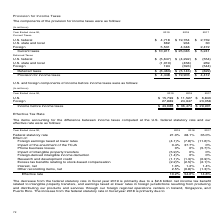According to Microsoft Corporation's financial document, Why did effective tax rate in fiscal 2019 decrease from 2018? Based on the financial document, the answer is The decrease in our effective tax rate for fiscal year 2019 compared to fiscal year 2018 was primarily due to the net charge related to the enactment of the TCJA in the second quarter of fiscal year 2018. Also, Why did the federal statutory rate in fiscal year 2019 decrease from 2018? The decrease from the federal statutory rate in fiscal year 2019 is primarily due to a $2.6 billion net income tax benefit related to intangible property transfers, and earnings taxed at lower rates in foreign jurisdictions resulting from producing and distributing our products and services through our foreign regional operations centers in Ireland, Singapore, and Puerto Rico.. The document states: "The decrease from the federal statutory rate in fiscal year 2019 is primarily due to a $2.6 billion net income tax benefit related to intangible prope..." Also, Why did the federal statutory rate in fiscal year 2017?  Based on the financial document, the answer is The decrease from the federal statutory rate in fiscal year 2017 is primarily due to earnings taxed at lower rates in foreign jurisdictions.. Also, How many items accounted for the difference between income taxes computed at the US federal statutory rate and the company's effective rate? Counting the relevant items in the document: Foreign earnings taxed at lower rates, Impact of the enactment of the TCJA, Phone business losses, Impact of intangible property transfers, Foreign-derived intangible income deduction, Research and development credit, Excess tax benefits relating to stock-based compensation, Interest, net, Other reconciling items, net, I find 9 instances. The key data points involved are: Excess tax benefits relating to stock-based compensation, Foreign earnings taxed at lower rates, Foreign-derived intangible income deduction. Also, can you calculate: What was the average federal statutory rate over the 3 year period from 2017 to 2019?  To answer this question, I need to perform calculations using the financial data. The calculation is: (21.0+28.1+35.0)/3, which equals 28.03 (percentage). This is based on the information: "Federal statutory rate 21.0% 28.1% 35.0% Federal statutory rate 21.0% 28.1% 35.0% Federal statutory rate 21.0% 28.1% 35.0%..." The key data points involved are: 21.0, 28.1, 35.0. Also, can you calculate: What was the average effective rate over the 3 year period from 2017 to 2019?  To answer this question, I need to perform calculations using the financial data. The calculation is: (10.2+54.6+14.8)/3, which equals 26.53 (percentage). This is based on the information: "Effective rate 10.2% 54.6% 14.8% Effective rate 10.2% 54.6% 14.8% Effective rate 10.2% 54.6% 14.8%..." The key data points involved are: 10.2, 14.8, 54.6. 